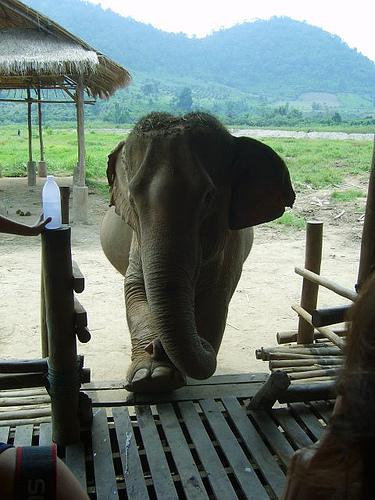Does this elephant have tusks?
Concise answer only. No. Is the elephant looking at the bottled water?
Concise answer only. Yes. Is the elephant full grown?
Short answer required. No. 